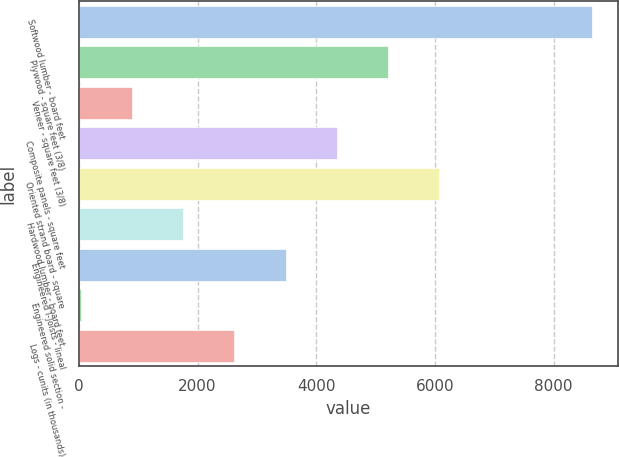Convert chart to OTSL. <chart><loc_0><loc_0><loc_500><loc_500><bar_chart><fcel>Softwood lumber - board feet<fcel>Plywood - square feet (3/8)<fcel>Veneer - square feet (3/8)<fcel>Composite panels - square feet<fcel>Oriented strand board - square<fcel>Hardwood lumber - board feet<fcel>Engineered I-Joists - lineal<fcel>Engineered solid section -<fcel>Logs - cunits (in thousands)<nl><fcel>8650<fcel>5205.2<fcel>899.2<fcel>4344<fcel>6066.4<fcel>1760.4<fcel>3482.8<fcel>38<fcel>2621.6<nl></chart> 